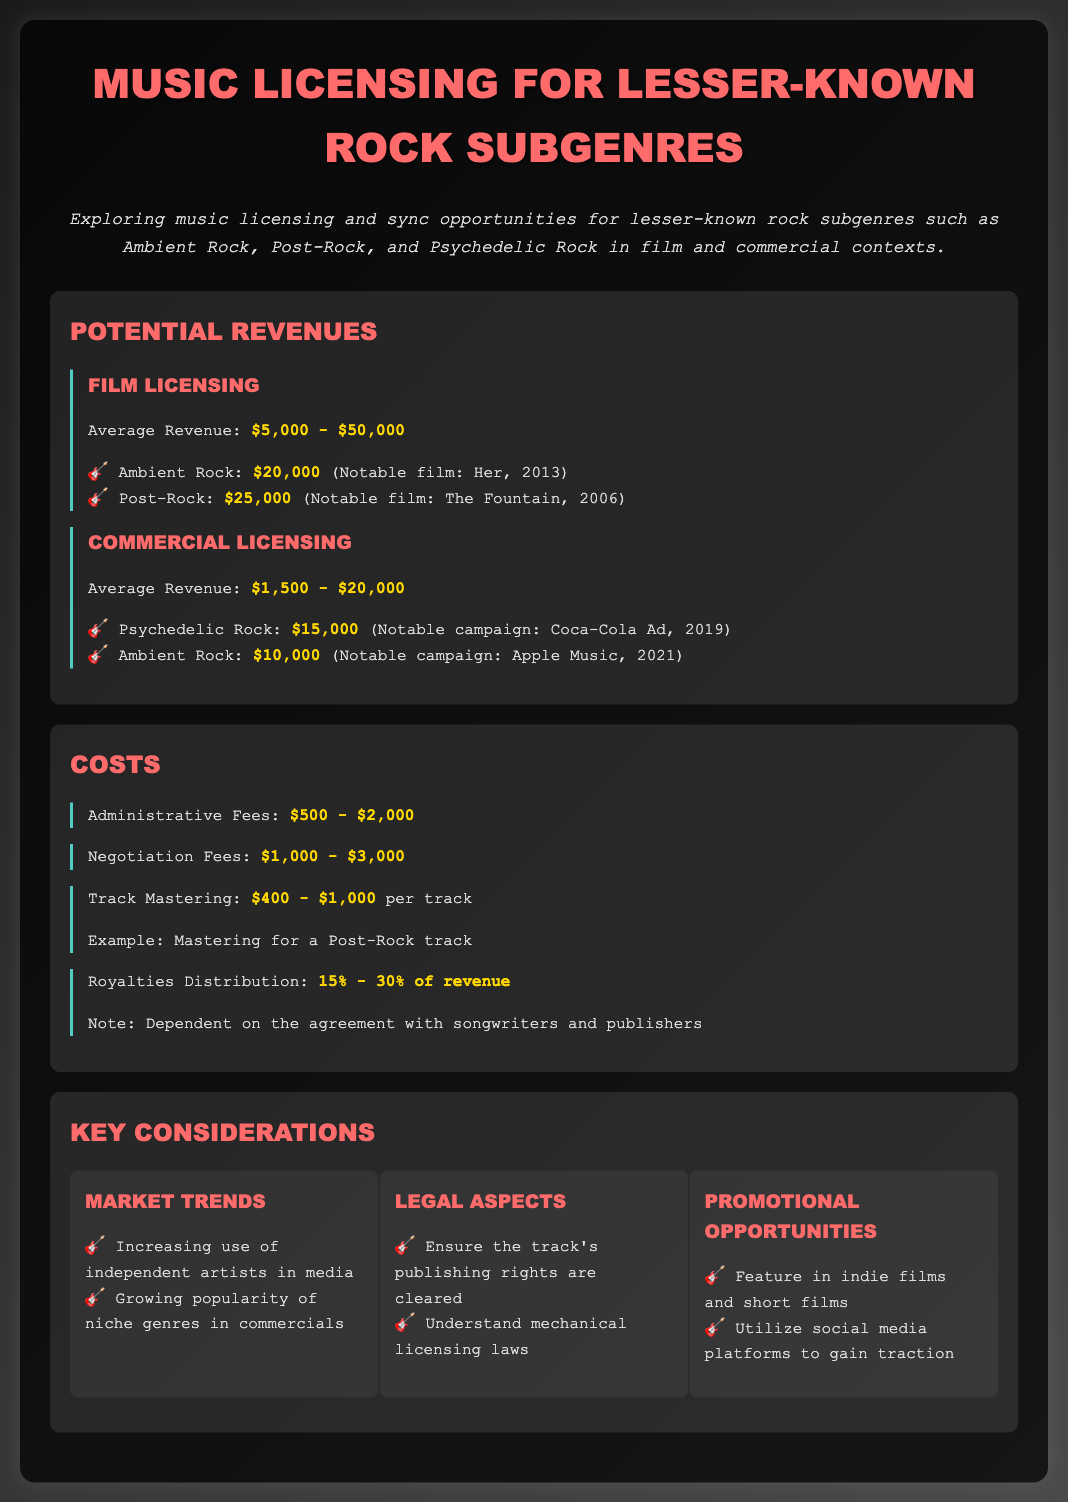What is the average revenue for film licensing? The average revenue for film licensing is stated in the document, which is $5,000 - $50,000.
Answer: $5,000 - $50,000 What is the notable film associated with Ambient Rock? The document mentions a notable film for Ambient Rock, which is Her, 2013.
Answer: Her, 2013 What are the costs associated with track mastering? The cost specified for track mastering is found in the document, which says $400 - $1,000 per track.
Answer: $400 - $1,000 What is the average revenue for commercial licensing? The document lists the average revenue for commercial licensing as $1,500 - $20,000.
Answer: $1,500 - $20,000 What percentage of revenue is typically allocated for royalties distribution? The document states that royalties distribution is typically 15% - 30% of revenue.
Answer: 15% - 30% Which subgenre earned $25,000 in a notable film? The document references this amount earned by Post-Rock in the film The Fountain, 2006.
Answer: Post-Rock What key consideration involves the increasing use of independent artists? The document outlines market trends, stating the increasing use of independent artists in media.
Answer: Market Trends Which notable campaign featured Psychedelic Rock? According to the document, the Coca-Cola Ad in 2019 featured Psychedelic Rock.
Answer: Coca-Cola Ad, 2019 What legal aspect is crucial for music licensing? The document highlights the need to ensure the track's publishing rights are cleared as a legal aspect.
Answer: Ensure publishing rights are cleared 